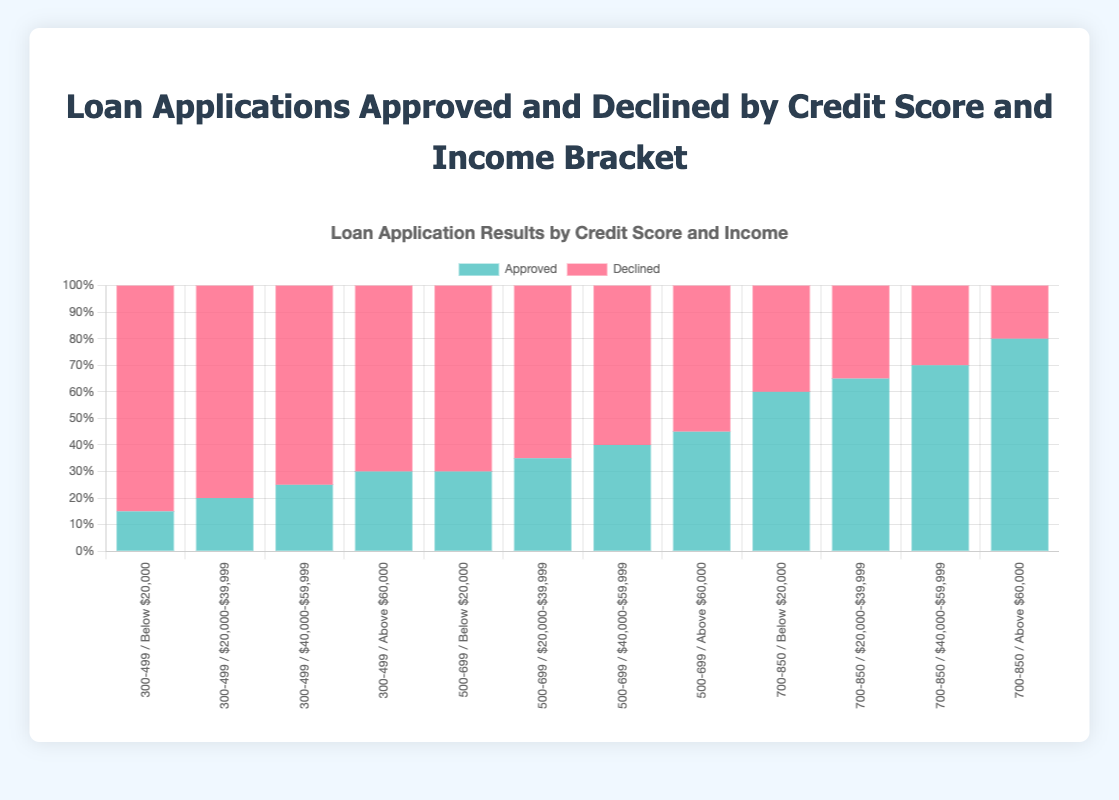Which credit score and income bracket combination has the highest number of loan applications approved? The highest number of loan applications approved is represented by the tallest blue bar in the chart. The blue bar for the combination of '700-850 / Above $60,000' is the tallest, indicating the highest number of approvals.
Answer: 700-850 / Above $60,000 What is the total number of loan applications (both approved and declined) for the '500-699 / $40,000-$59,999' bracket? For this bracket, we sum the approved and declined applications: 40 (Approved) + 60 (Declined) = 100.
Answer: 100 Is there any combination where the number of declined applications is less than the number of approved applications? A quick comparison of the height of the blue (approved) and red (declined) bars shows that for the combination '700-850 / Above $60,000', the approved applications (80) exceed the declined applications (20). This is the only combination meeting the criteria.
Answer: Yes, '700-850 / Above $60,000' Which income bracket shows the most significant difference between approved and declined applications for the '300-499' credit score range? We calculate the absolute difference for each income bracket under '300-499': 'Below $20,000' has 85 - 15 = 70, '$20,000-$39,999' has 80 - 20 = 60, '$40,000-$59,999' has 75 - 25 = 50, and 'Above $60,000' has 70 - 30 = 40. The largest difference is for 'Below $20,000' with a difference of 70.
Answer: Below $20,000 How does the approval rate (percentage of approved applications) change as the income bracket increases within the '500-699' credit score range? We calculate the approval rate for each income bracket within the '500-699' range: 
'Below $20,000': 30/(30+70) = 30%, 
'$20,000-$39,999': 35/(35+65) = 35%, 
'$40,000-$59,999': 40/(40+60) = 40%, 
'Above $60,000': 45/(45+55) = 45%. 
The approval rate increases as the income bracket increases.
Answer: Increases For the '700-850' credit score range, which income bracket has the smallest difference between approved and declined applications? Calculate the differences: 
'Below $20,000': 60 - 40 = 20, 
'$20,000-$39,999': 65 - 35 = 30, 
'$40,000-$59,999': 70 - 30 = 40, 
'Above $60,000': 80 - 20 = 60. 
The 'Below $20,000' bracket has the smallest difference of 20.
Answer: Below $20,000 What is the overall approval rate across all credit score ranges and income brackets? Sum all approvals and declines: Total approved = 15+20+25+30+30+35+40+45+60+65+70+80 = 515, Total declined = 85+80+75+70+70+65+60+55+40+35+30+20 = 685, Total applications = 515 + 685 = 1200. Approval rate = (515/1200) * 100 ≈ 42.92%.
Answer: 42.92% Compare the height of the bars for 'Approved' and 'Declined' applications for the '500-699 / $20,000-$39,999' combination. Which is taller? For this combination, the height of the 'Declined' (red) bar is taller than the 'Approved' (blue) bar.
Answer: Declined 